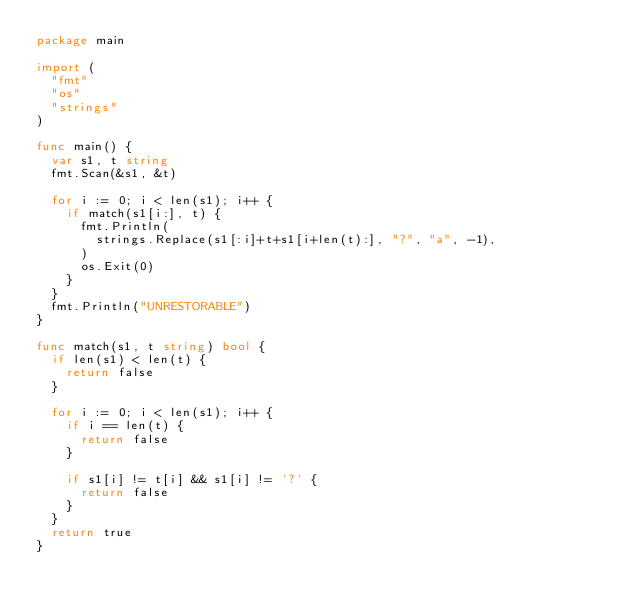Convert code to text. <code><loc_0><loc_0><loc_500><loc_500><_Go_>package main

import (
	"fmt"
	"os"
	"strings"
)

func main() {
	var s1, t string
	fmt.Scan(&s1, &t)

	for i := 0; i < len(s1); i++ {
		if match(s1[i:], t) {
			fmt.Println(
				strings.Replace(s1[:i]+t+s1[i+len(t):], "?", "a", -1),
			)
			os.Exit(0)
		}
	}
	fmt.Println("UNRESTORABLE")
}

func match(s1, t string) bool {
	if len(s1) < len(t) {
		return false
	}

	for i := 0; i < len(s1); i++ {
		if i == len(t) {
			return false
		}

		if s1[i] != t[i] && s1[i] != '?' {
			return false
		}
	}
	return true
}
</code> 